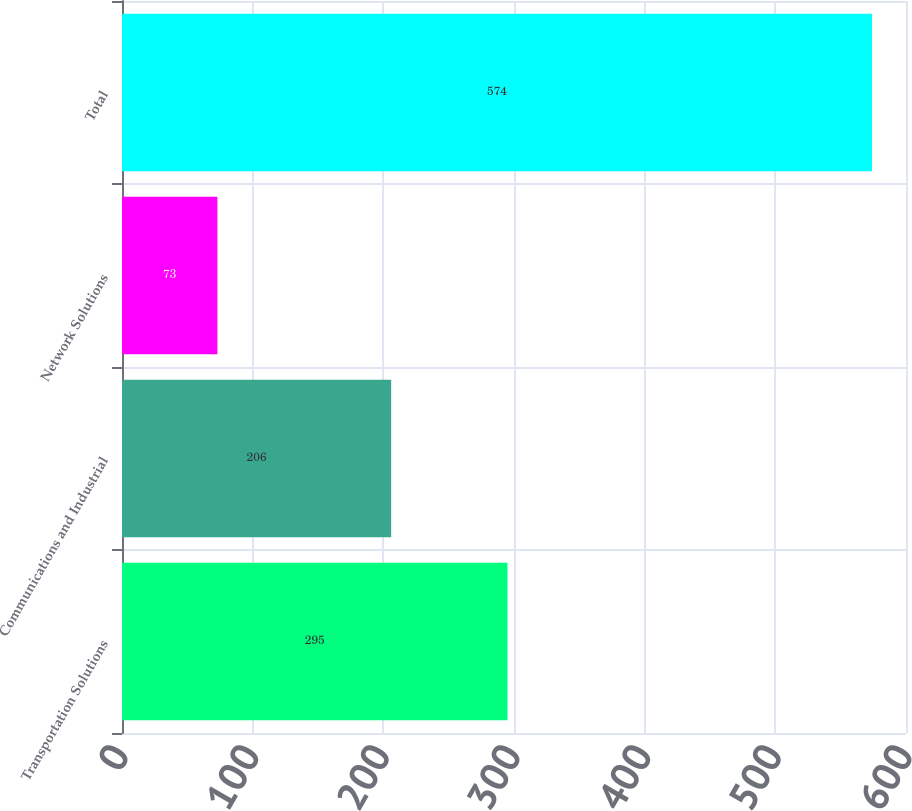Convert chart. <chart><loc_0><loc_0><loc_500><loc_500><bar_chart><fcel>Transportation Solutions<fcel>Communications and Industrial<fcel>Network Solutions<fcel>Total<nl><fcel>295<fcel>206<fcel>73<fcel>574<nl></chart> 